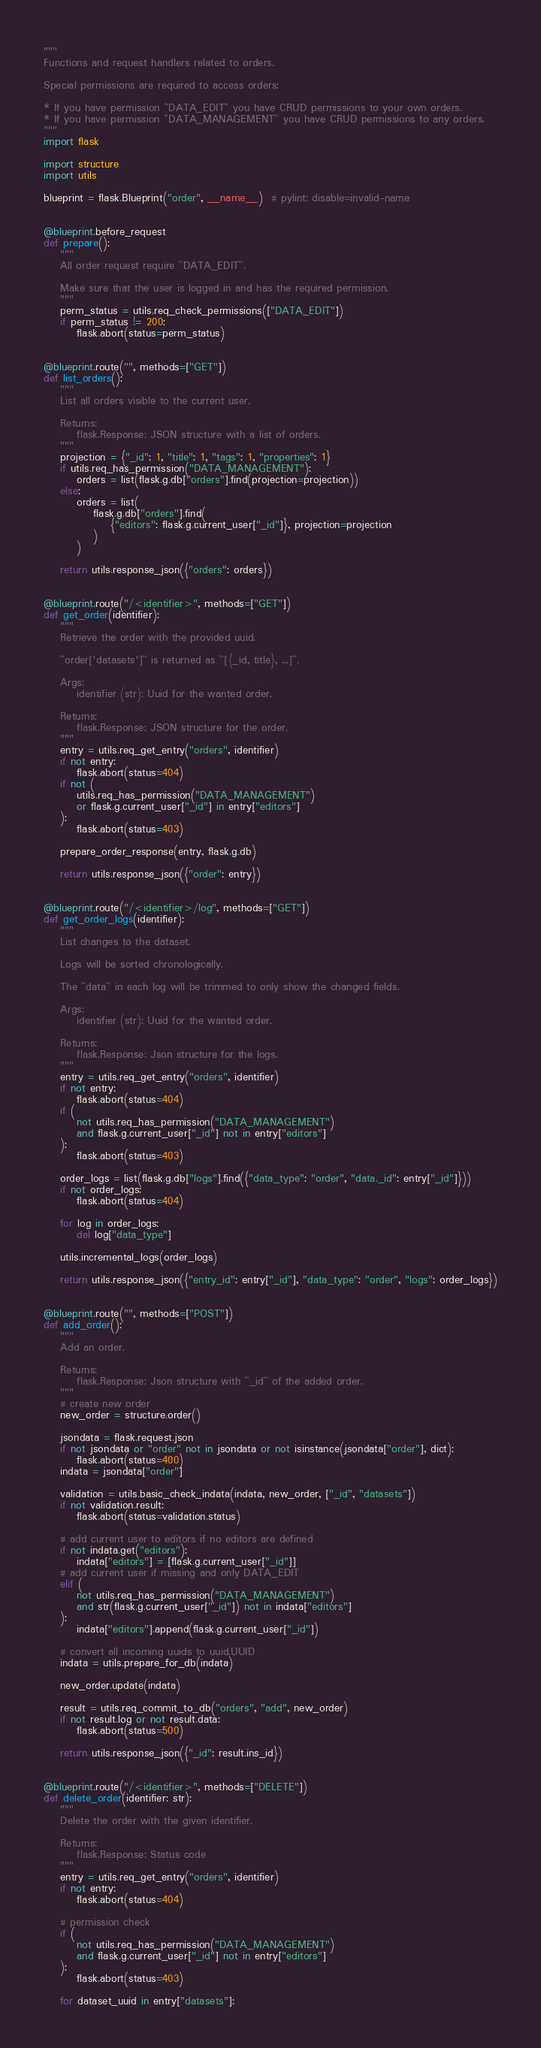Convert code to text. <code><loc_0><loc_0><loc_500><loc_500><_Python_>"""
Functions and request handlers related to orders.

Special permissions are required to access orders:

* If you have permission ``DATA_EDIT`` you have CRUD permissions to your own orders.
* If you have permission ``DATA_MANAGEMENT`` you have CRUD permissions to any orders.
"""
import flask

import structure
import utils

blueprint = flask.Blueprint("order", __name__)  # pylint: disable=invalid-name


@blueprint.before_request
def prepare():
    """
    All order request require ``DATA_EDIT``.

    Make sure that the user is logged in and has the required permission.
    """
    perm_status = utils.req_check_permissions(["DATA_EDIT"])
    if perm_status != 200:
        flask.abort(status=perm_status)


@blueprint.route("", methods=["GET"])
def list_orders():
    """
    List all orders visible to the current user.

    Returns:
        flask.Response: JSON structure with a list of orders.
    """
    projection = {"_id": 1, "title": 1, "tags": 1, "properties": 1}
    if utils.req_has_permission("DATA_MANAGEMENT"):
        orders = list(flask.g.db["orders"].find(projection=projection))
    else:
        orders = list(
            flask.g.db["orders"].find(
                {"editors": flask.g.current_user["_id"]}, projection=projection
            )
        )

    return utils.response_json({"orders": orders})


@blueprint.route("/<identifier>", methods=["GET"])
def get_order(identifier):
    """
    Retrieve the order with the provided uuid.

    ``order['datasets']`` is returned as ``[{_id, title}, ...]``.

    Args:
        identifier (str): Uuid for the wanted order.

    Returns:
        flask.Response: JSON structure for the order.
    """
    entry = utils.req_get_entry("orders", identifier)
    if not entry:
        flask.abort(status=404)
    if not (
        utils.req_has_permission("DATA_MANAGEMENT")
        or flask.g.current_user["_id"] in entry["editors"]
    ):
        flask.abort(status=403)

    prepare_order_response(entry, flask.g.db)

    return utils.response_json({"order": entry})


@blueprint.route("/<identifier>/log", methods=["GET"])
def get_order_logs(identifier):
    """
    List changes to the dataset.

    Logs will be sorted chronologically.

    The ``data`` in each log will be trimmed to only show the changed fields.

    Args:
        identifier (str): Uuid for the wanted order.

    Returns:
        flask.Response: Json structure for the logs.
    """
    entry = utils.req_get_entry("orders", identifier)
    if not entry:
        flask.abort(status=404)
    if (
        not utils.req_has_permission("DATA_MANAGEMENT")
        and flask.g.current_user["_id"] not in entry["editors"]
    ):
        flask.abort(status=403)

    order_logs = list(flask.g.db["logs"].find({"data_type": "order", "data._id": entry["_id"]}))
    if not order_logs:
        flask.abort(status=404)

    for log in order_logs:
        del log["data_type"]

    utils.incremental_logs(order_logs)

    return utils.response_json({"entry_id": entry["_id"], "data_type": "order", "logs": order_logs})


@blueprint.route("", methods=["POST"])
def add_order():
    """
    Add an order.

    Returns:
        flask.Response: Json structure with ``_id`` of the added order.
    """
    # create new order
    new_order = structure.order()

    jsondata = flask.request.json
    if not jsondata or "order" not in jsondata or not isinstance(jsondata["order"], dict):
        flask.abort(status=400)
    indata = jsondata["order"]

    validation = utils.basic_check_indata(indata, new_order, ["_id", "datasets"])
    if not validation.result:
        flask.abort(status=validation.status)

    # add current user to editors if no editors are defined
    if not indata.get("editors"):
        indata["editors"] = [flask.g.current_user["_id"]]
    # add current user if missing and only DATA_EDIT
    elif (
        not utils.req_has_permission("DATA_MANAGEMENT")
        and str(flask.g.current_user["_id"]) not in indata["editors"]
    ):
        indata["editors"].append(flask.g.current_user["_id"])

    # convert all incoming uuids to uuid.UUID
    indata = utils.prepare_for_db(indata)

    new_order.update(indata)

    result = utils.req_commit_to_db("orders", "add", new_order)
    if not result.log or not result.data:
        flask.abort(status=500)

    return utils.response_json({"_id": result.ins_id})


@blueprint.route("/<identifier>", methods=["DELETE"])
def delete_order(identifier: str):
    """
    Delete the order with the given identifier.

    Returns:
        flask.Response: Status code
    """
    entry = utils.req_get_entry("orders", identifier)
    if not entry:
        flask.abort(status=404)

    # permission check
    if (
        not utils.req_has_permission("DATA_MANAGEMENT")
        and flask.g.current_user["_id"] not in entry["editors"]
    ):
        flask.abort(status=403)

    for dataset_uuid in entry["datasets"]:</code> 